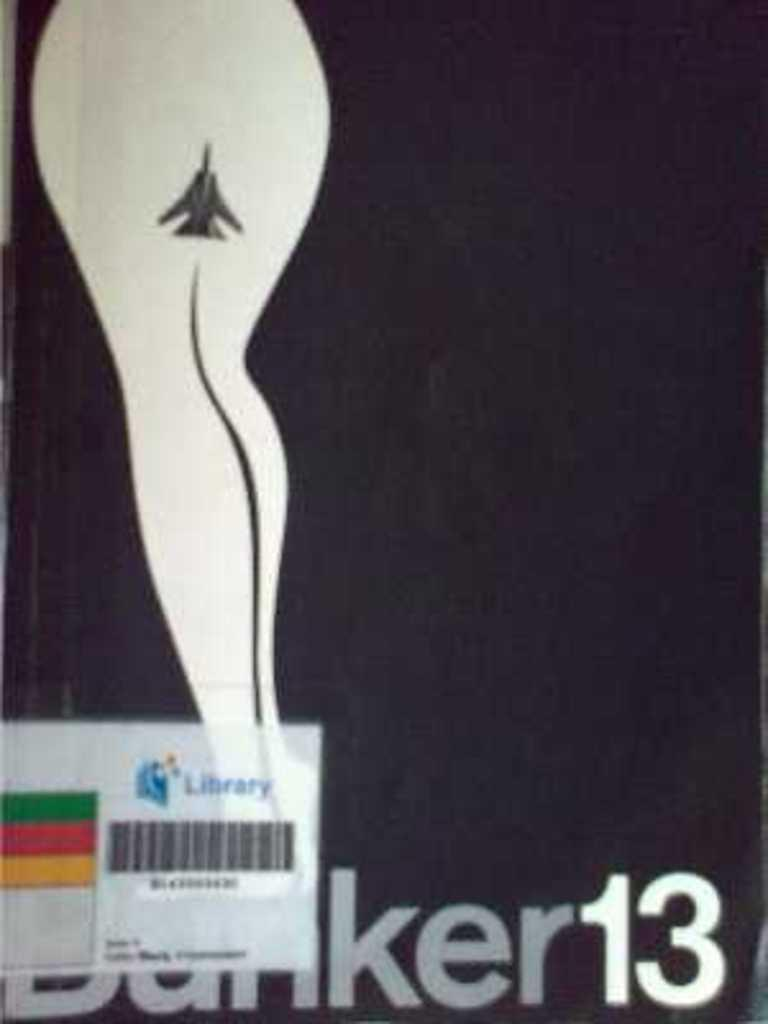What is the main subject of the image? The main subject of the image is a picture of a person's leg. Are there any additional elements in the image besides the leg? Yes, there is a barcode and text at the bottom of the image. How many bees can be seen crawling on the person's leg in the image? There are no bees present in the image; it only features a picture of a person's leg, a barcode, and text at the bottom. What type of wool is used to make the person's socks in the image? There is no information about the person's socks or the type of wool used in the image. 